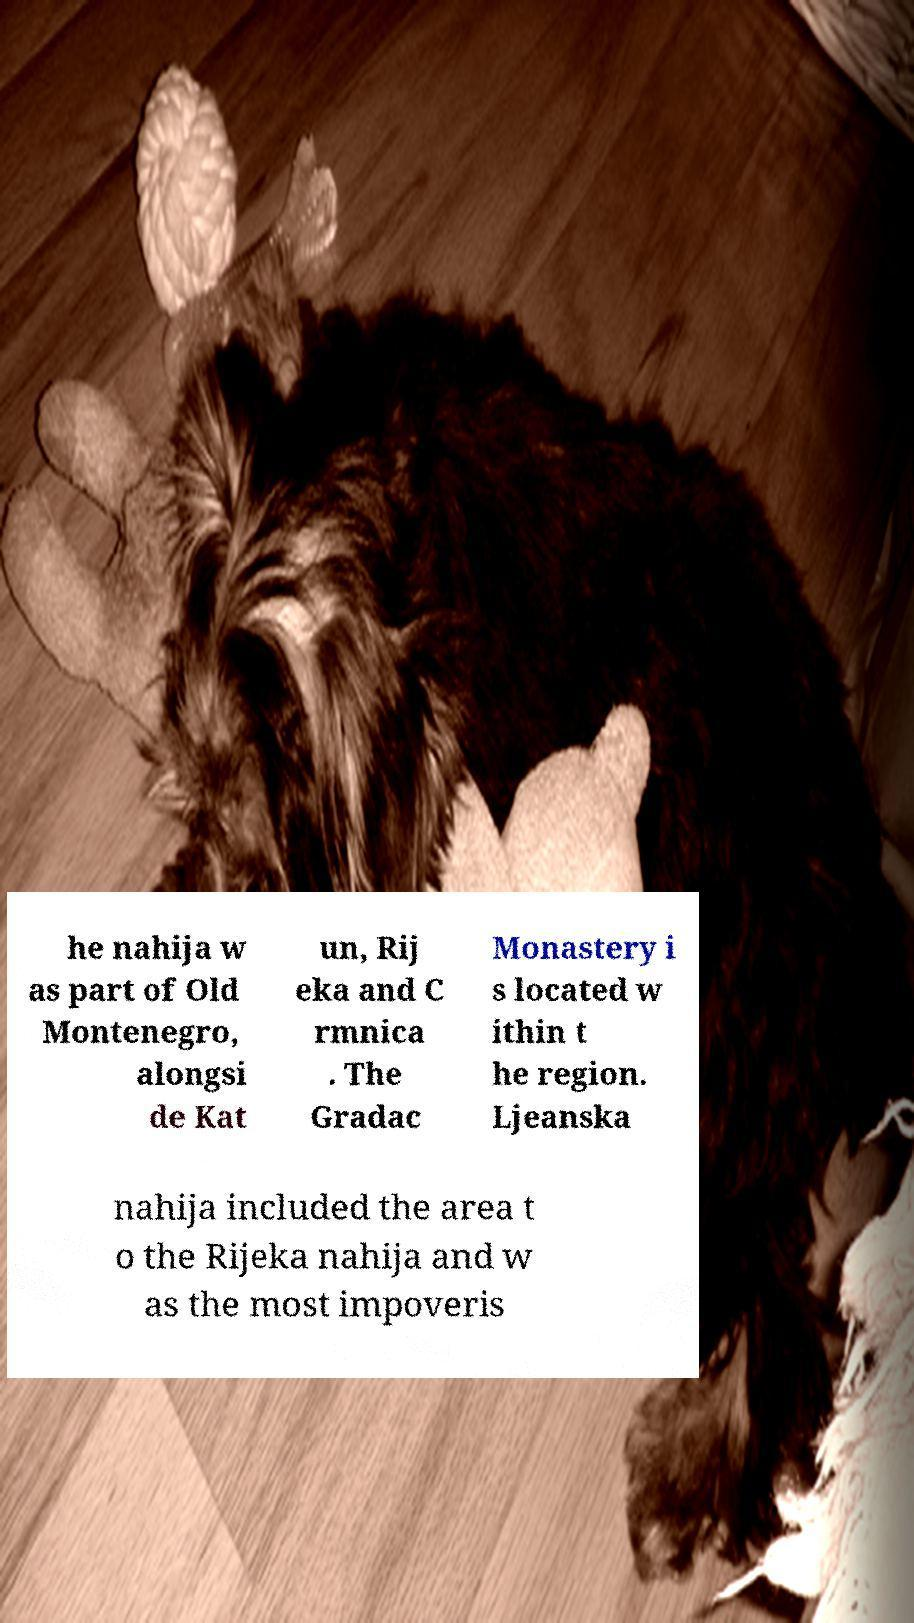For documentation purposes, I need the text within this image transcribed. Could you provide that? he nahija w as part of Old Montenegro, alongsi de Kat un, Rij eka and C rmnica . The Gradac Monastery i s located w ithin t he region. Ljeanska nahija included the area t o the Rijeka nahija and w as the most impoveris 